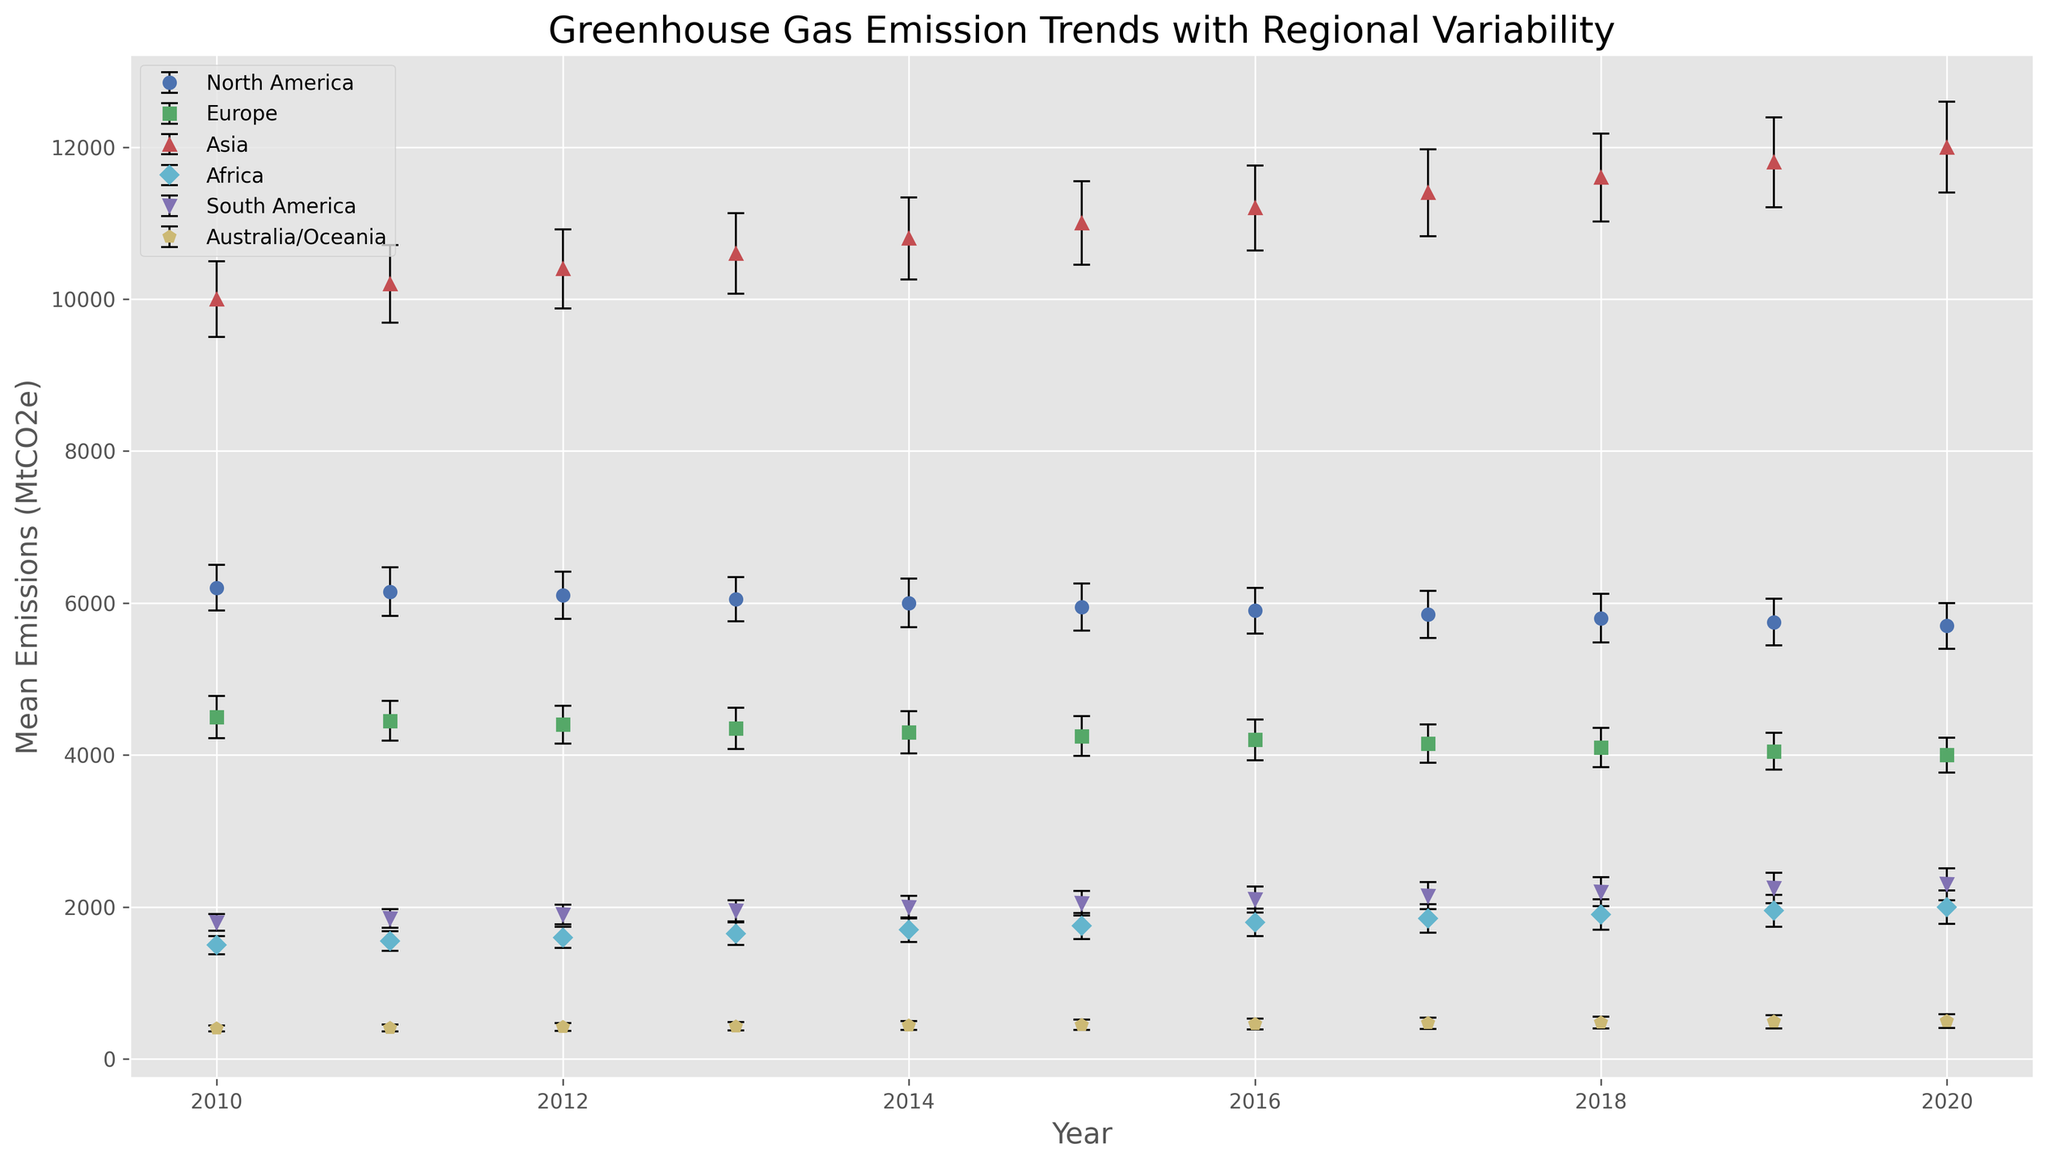Which region had the highest greenhouse gas emissions in 2020? To determine the region with the highest emissions in 2020, compare the mean emissions (bar heights) for each region in 2020. Asia’s mean emissions are the highest.
Answer: Asia Which region shows the largest decrease in greenhouse gas emissions from 2010 to 2020? Subtract the 2020 emissions from the 2010 emissions for each region and compare the differences. North America shows a decrease from 6200 to 5700 MtCO2e, a drop of 500 MtCO2e.
Answer: North America What is the average greenhouse gas emission of North America between 2010 and 2020? Sum the emissions of North America from 2010 to 2020 and divide by the number of years: (6200 + 6150 + 6100 + 6050 + 6000 + 5950 + 5900 + 5850 + 5800 + 5750 + 5700) / 11 = 5977.27 MtCO2e.
Answer: 5977.27 MtCO2e Which regions show an upward trend in greenhouse gas emissions over the given period? Observe the trends of the mean emissions for each region from 2010 to 2020. Regions like Asia, Africa, South America, and Australia/Oceania show an upward trend.
Answer: Asia, Africa, South America, Australia/Oceania Between 2015 and 2020, which region has the smallest variation in its greenhouse gas emissions? Calculate the range (maximum - minimum) of emissions between 2015 and 2020 for each region. Europe has the smallest range (4250 to 4000 MtCO2e), a variation of 250 MtCO2e.
Answer: Europe Which region had the lowest average emissions over the entire period? Calculate the average emissions for each region from 2010 to 2020, then determine the lowest. Australia/Oceania has the lowest average: (400 + 410 + 420 + 430 + 440 + 450 + 460 + 470 + 480 + 490 + 500) / 11 = 445 MtCO2e.
Answer: Australia/Oceania In which year did Europe’s emissions first fall below 4300 MtCO2e? Scan through the data points for Europe and identify the year when emissions first dropped below 4300. This occurred in 2016 with emissions of 4200 MtCO2e.
Answer: 2016 Do any regions have overlapping error bars in 2020, indicating similar levels of variability in emissions? Check if error bars (vertical lines) overlap in 2020 among different regions. North America and Europe have overlapping error bars, indicating similar variability.
Answer: North America, Europe 